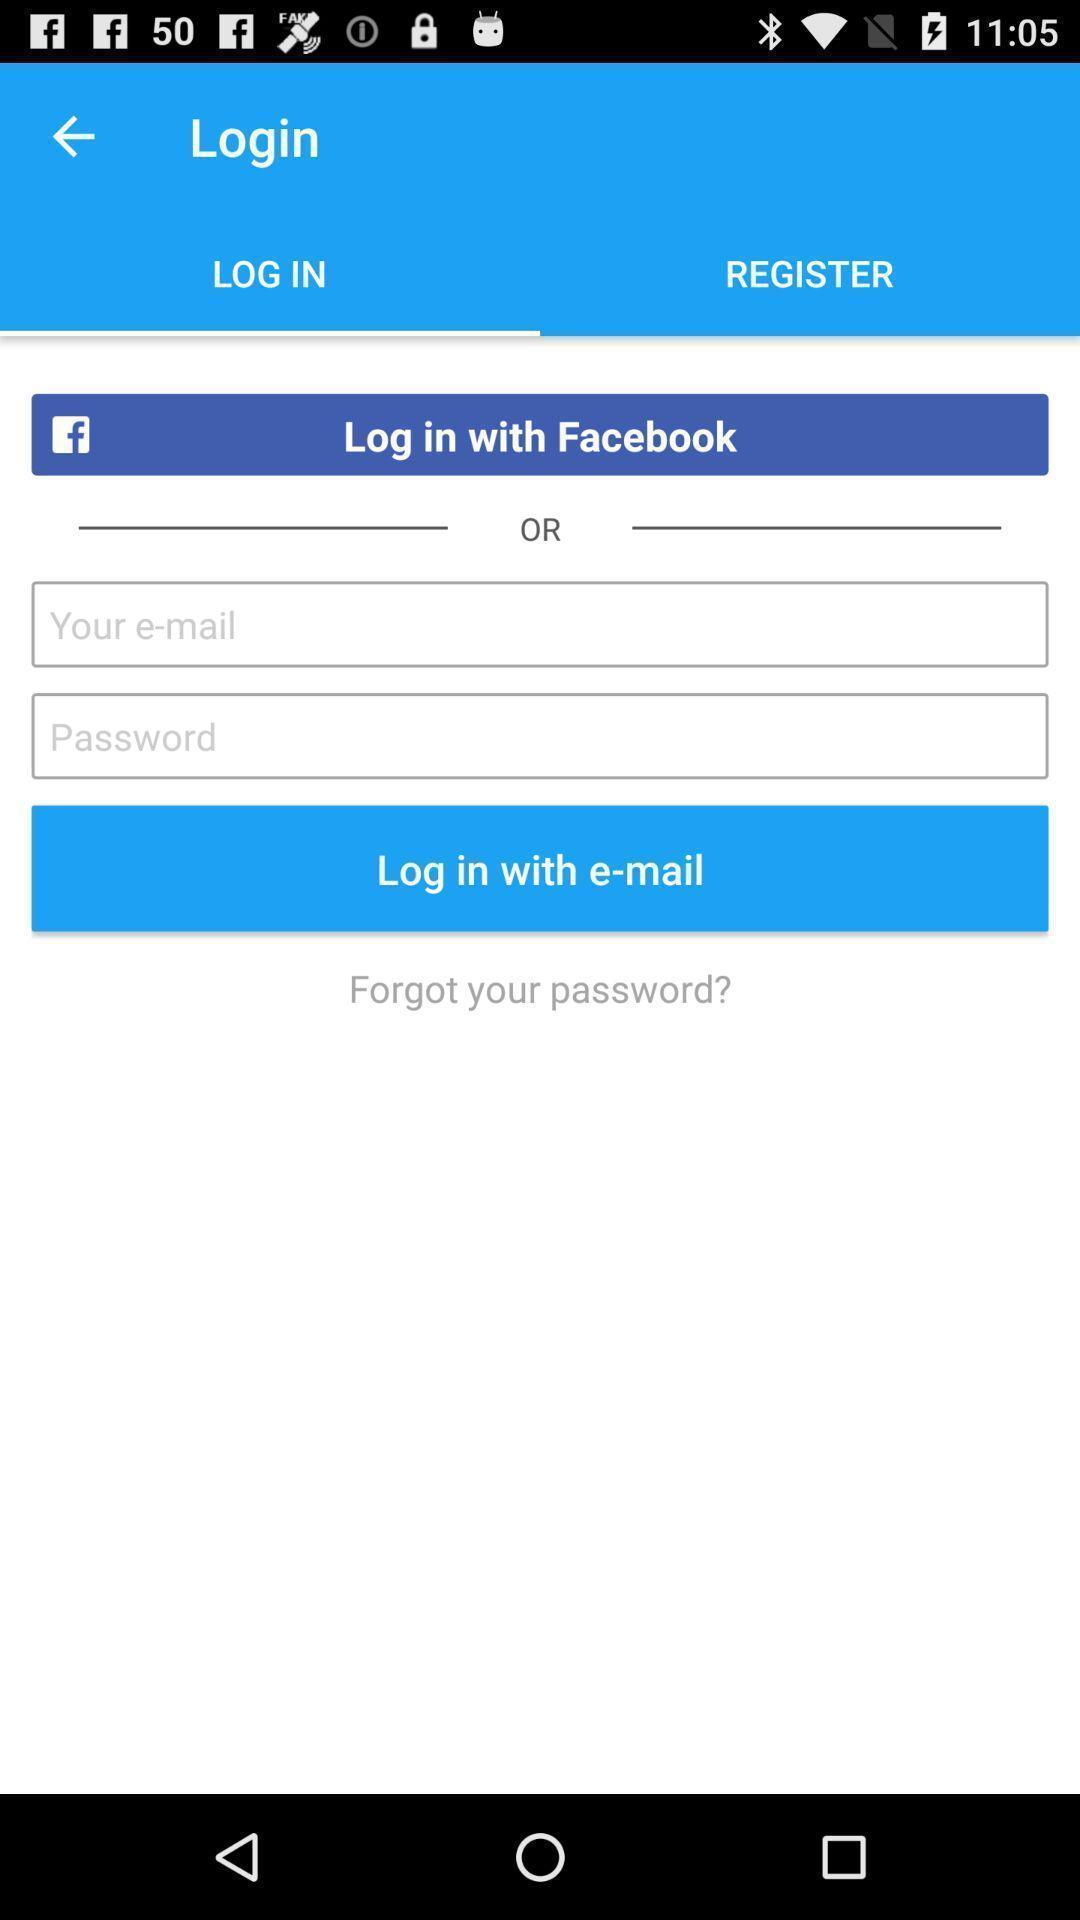Describe this image in words. Window displaying log in page. 